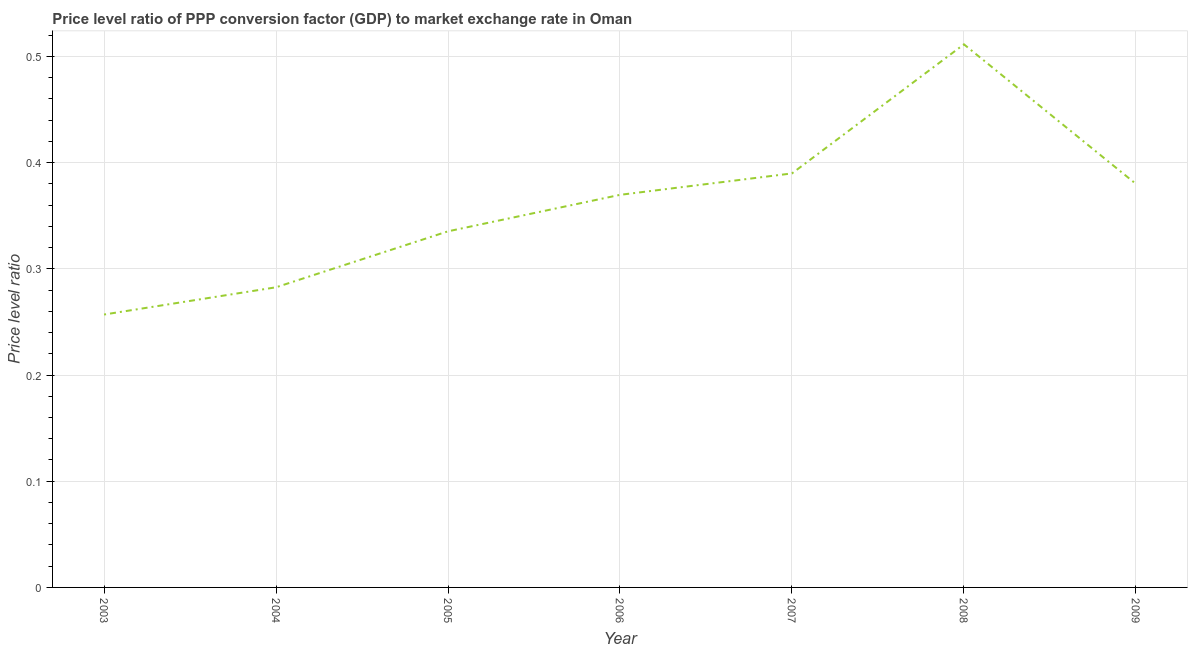What is the price level ratio in 2003?
Keep it short and to the point. 0.26. Across all years, what is the maximum price level ratio?
Provide a short and direct response. 0.51. Across all years, what is the minimum price level ratio?
Provide a short and direct response. 0.26. In which year was the price level ratio maximum?
Your answer should be very brief. 2008. What is the sum of the price level ratio?
Your answer should be compact. 2.53. What is the difference between the price level ratio in 2003 and 2004?
Make the answer very short. -0.03. What is the average price level ratio per year?
Your answer should be very brief. 0.36. What is the median price level ratio?
Your response must be concise. 0.37. What is the ratio of the price level ratio in 2005 to that in 2006?
Your response must be concise. 0.91. Is the price level ratio in 2003 less than that in 2004?
Offer a very short reply. Yes. What is the difference between the highest and the second highest price level ratio?
Your answer should be compact. 0.12. Is the sum of the price level ratio in 2003 and 2006 greater than the maximum price level ratio across all years?
Give a very brief answer. Yes. What is the difference between the highest and the lowest price level ratio?
Make the answer very short. 0.25. What is the difference between two consecutive major ticks on the Y-axis?
Ensure brevity in your answer.  0.1. Does the graph contain grids?
Make the answer very short. Yes. What is the title of the graph?
Make the answer very short. Price level ratio of PPP conversion factor (GDP) to market exchange rate in Oman. What is the label or title of the Y-axis?
Ensure brevity in your answer.  Price level ratio. What is the Price level ratio of 2003?
Provide a short and direct response. 0.26. What is the Price level ratio of 2004?
Your answer should be compact. 0.28. What is the Price level ratio in 2005?
Make the answer very short. 0.34. What is the Price level ratio of 2006?
Give a very brief answer. 0.37. What is the Price level ratio of 2007?
Your answer should be very brief. 0.39. What is the Price level ratio of 2008?
Offer a terse response. 0.51. What is the Price level ratio in 2009?
Your answer should be very brief. 0.38. What is the difference between the Price level ratio in 2003 and 2004?
Make the answer very short. -0.03. What is the difference between the Price level ratio in 2003 and 2005?
Your answer should be compact. -0.08. What is the difference between the Price level ratio in 2003 and 2006?
Offer a very short reply. -0.11. What is the difference between the Price level ratio in 2003 and 2007?
Ensure brevity in your answer.  -0.13. What is the difference between the Price level ratio in 2003 and 2008?
Provide a succinct answer. -0.25. What is the difference between the Price level ratio in 2003 and 2009?
Keep it short and to the point. -0.12. What is the difference between the Price level ratio in 2004 and 2005?
Provide a short and direct response. -0.05. What is the difference between the Price level ratio in 2004 and 2006?
Your answer should be compact. -0.09. What is the difference between the Price level ratio in 2004 and 2007?
Your answer should be compact. -0.11. What is the difference between the Price level ratio in 2004 and 2008?
Ensure brevity in your answer.  -0.23. What is the difference between the Price level ratio in 2004 and 2009?
Offer a very short reply. -0.1. What is the difference between the Price level ratio in 2005 and 2006?
Keep it short and to the point. -0.03. What is the difference between the Price level ratio in 2005 and 2007?
Your answer should be very brief. -0.05. What is the difference between the Price level ratio in 2005 and 2008?
Offer a terse response. -0.18. What is the difference between the Price level ratio in 2005 and 2009?
Give a very brief answer. -0.04. What is the difference between the Price level ratio in 2006 and 2007?
Provide a succinct answer. -0.02. What is the difference between the Price level ratio in 2006 and 2008?
Provide a succinct answer. -0.14. What is the difference between the Price level ratio in 2006 and 2009?
Keep it short and to the point. -0.01. What is the difference between the Price level ratio in 2007 and 2008?
Provide a succinct answer. -0.12. What is the difference between the Price level ratio in 2007 and 2009?
Ensure brevity in your answer.  0.01. What is the difference between the Price level ratio in 2008 and 2009?
Offer a terse response. 0.13. What is the ratio of the Price level ratio in 2003 to that in 2004?
Give a very brief answer. 0.91. What is the ratio of the Price level ratio in 2003 to that in 2005?
Keep it short and to the point. 0.77. What is the ratio of the Price level ratio in 2003 to that in 2006?
Provide a short and direct response. 0.69. What is the ratio of the Price level ratio in 2003 to that in 2007?
Make the answer very short. 0.66. What is the ratio of the Price level ratio in 2003 to that in 2008?
Your answer should be very brief. 0.5. What is the ratio of the Price level ratio in 2003 to that in 2009?
Give a very brief answer. 0.68. What is the ratio of the Price level ratio in 2004 to that in 2005?
Your answer should be very brief. 0.84. What is the ratio of the Price level ratio in 2004 to that in 2006?
Ensure brevity in your answer.  0.77. What is the ratio of the Price level ratio in 2004 to that in 2007?
Ensure brevity in your answer.  0.72. What is the ratio of the Price level ratio in 2004 to that in 2008?
Provide a short and direct response. 0.55. What is the ratio of the Price level ratio in 2004 to that in 2009?
Make the answer very short. 0.74. What is the ratio of the Price level ratio in 2005 to that in 2006?
Your answer should be very brief. 0.91. What is the ratio of the Price level ratio in 2005 to that in 2007?
Your answer should be very brief. 0.86. What is the ratio of the Price level ratio in 2005 to that in 2008?
Your response must be concise. 0.66. What is the ratio of the Price level ratio in 2005 to that in 2009?
Ensure brevity in your answer.  0.88. What is the ratio of the Price level ratio in 2006 to that in 2007?
Keep it short and to the point. 0.95. What is the ratio of the Price level ratio in 2006 to that in 2008?
Give a very brief answer. 0.72. What is the ratio of the Price level ratio in 2006 to that in 2009?
Make the answer very short. 0.97. What is the ratio of the Price level ratio in 2007 to that in 2008?
Your answer should be very brief. 0.76. What is the ratio of the Price level ratio in 2008 to that in 2009?
Make the answer very short. 1.35. 